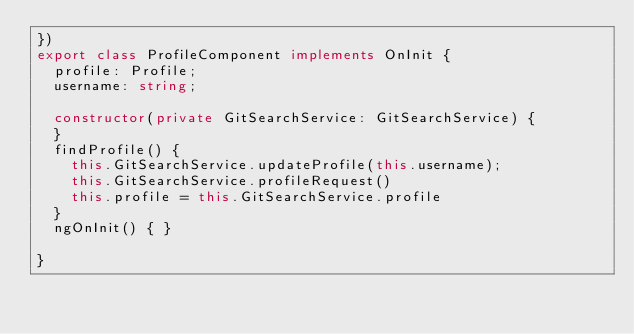Convert code to text. <code><loc_0><loc_0><loc_500><loc_500><_TypeScript_>})
export class ProfileComponent implements OnInit {
  profile: Profile;
  username: string;

  constructor(private GitSearchService: GitSearchService) {
  }
  findProfile() {
    this.GitSearchService.updateProfile(this.username);
    this.GitSearchService.profileRequest()
    this.profile = this.GitSearchService.profile
  }
  ngOnInit() { }

}
</code> 